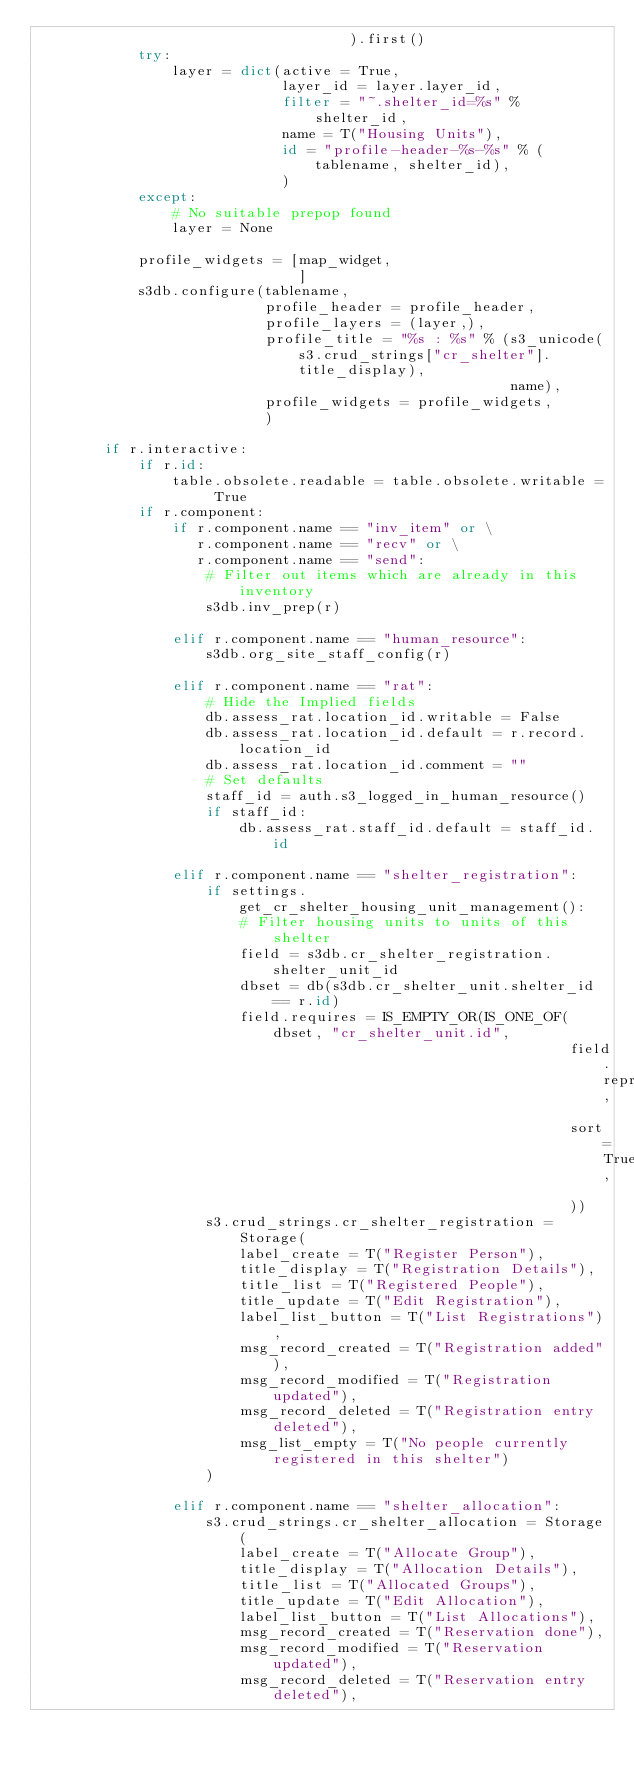Convert code to text. <code><loc_0><loc_0><loc_500><loc_500><_Python_>                                     ).first()
            try:
                layer = dict(active = True,
                             layer_id = layer.layer_id,
                             filter = "~.shelter_id=%s" % shelter_id,
                             name = T("Housing Units"),
                             id = "profile-header-%s-%s" % (tablename, shelter_id),
                             )
            except:
                # No suitable prepop found
                layer = None

            profile_widgets = [map_widget,
                               ]
            s3db.configure(tablename,
                           profile_header = profile_header,
                           profile_layers = (layer,),
                           profile_title = "%s : %s" % (s3_unicode(s3.crud_strings["cr_shelter"].title_display),
                                                        name),
                           profile_widgets = profile_widgets,
                           )

        if r.interactive:
            if r.id:
                table.obsolete.readable = table.obsolete.writable = True
            if r.component:
                if r.component.name == "inv_item" or \
                   r.component.name == "recv" or \
                   r.component.name == "send":
                    # Filter out items which are already in this inventory
                    s3db.inv_prep(r)

                elif r.component.name == "human_resource":
                    s3db.org_site_staff_config(r)

                elif r.component.name == "rat":
                    # Hide the Implied fields
                    db.assess_rat.location_id.writable = False
                    db.assess_rat.location_id.default = r.record.location_id
                    db.assess_rat.location_id.comment = ""
                    # Set defaults
                    staff_id = auth.s3_logged_in_human_resource()
                    if staff_id:
                        db.assess_rat.staff_id.default = staff_id.id

                elif r.component.name == "shelter_registration":
                    if settings.get_cr_shelter_housing_unit_management():
                        # Filter housing units to units of this shelter
                        field = s3db.cr_shelter_registration.shelter_unit_id
                        dbset = db(s3db.cr_shelter_unit.shelter_id == r.id)
                        field.requires = IS_EMPTY_OR(IS_ONE_OF(dbset, "cr_shelter_unit.id",
                                                               field.represent,
                                                               sort=True,
                                                               ))
                    s3.crud_strings.cr_shelter_registration = Storage(
                        label_create = T("Register Person"),
                        title_display = T("Registration Details"),
                        title_list = T("Registered People"),
                        title_update = T("Edit Registration"),
                        label_list_button = T("List Registrations"),
                        msg_record_created = T("Registration added"),
                        msg_record_modified = T("Registration updated"),
                        msg_record_deleted = T("Registration entry deleted"),
                        msg_list_empty = T("No people currently registered in this shelter")
                    )

                elif r.component.name == "shelter_allocation":
                    s3.crud_strings.cr_shelter_allocation = Storage(
                        label_create = T("Allocate Group"),
                        title_display = T("Allocation Details"),
                        title_list = T("Allocated Groups"),
                        title_update = T("Edit Allocation"),
                        label_list_button = T("List Allocations"),
                        msg_record_created = T("Reservation done"),
                        msg_record_modified = T("Reservation updated"),
                        msg_record_deleted = T("Reservation entry deleted"),</code> 